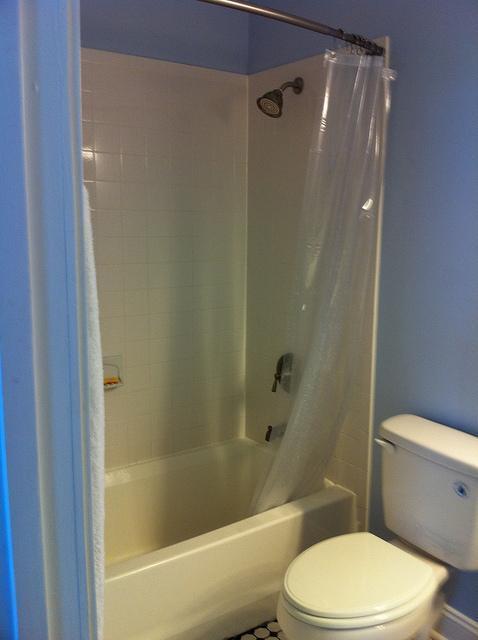How many toilets are in the picture?
Give a very brief answer. 1. 